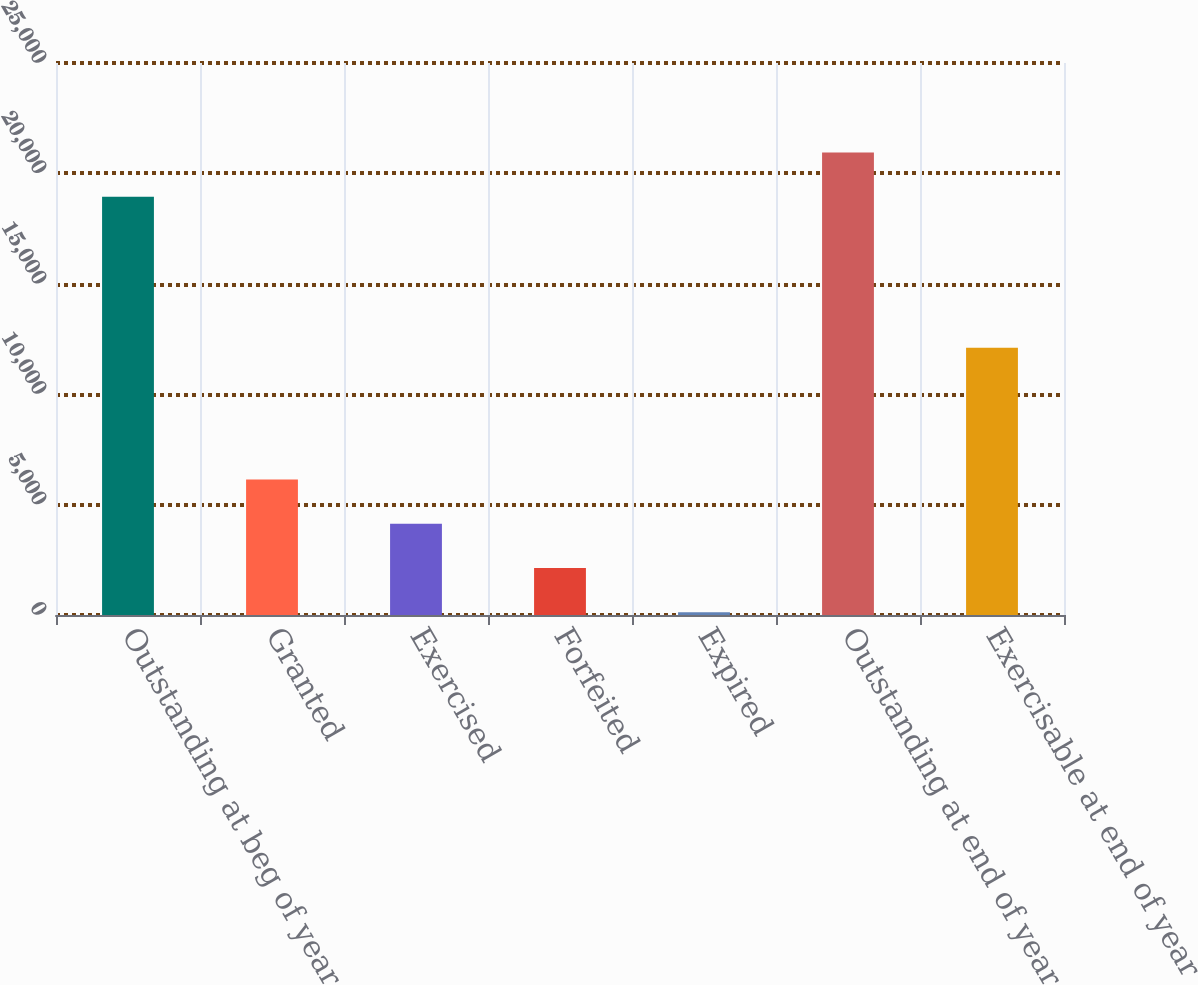Convert chart to OTSL. <chart><loc_0><loc_0><loc_500><loc_500><bar_chart><fcel>Outstanding at beg of year<fcel>Granted<fcel>Exercised<fcel>Forfeited<fcel>Expired<fcel>Outstanding at end of year<fcel>Exercisable at end of year<nl><fcel>18937<fcel>6137.7<fcel>4132.8<fcel>2127.9<fcel>123<fcel>20941.9<fcel>12099<nl></chart> 